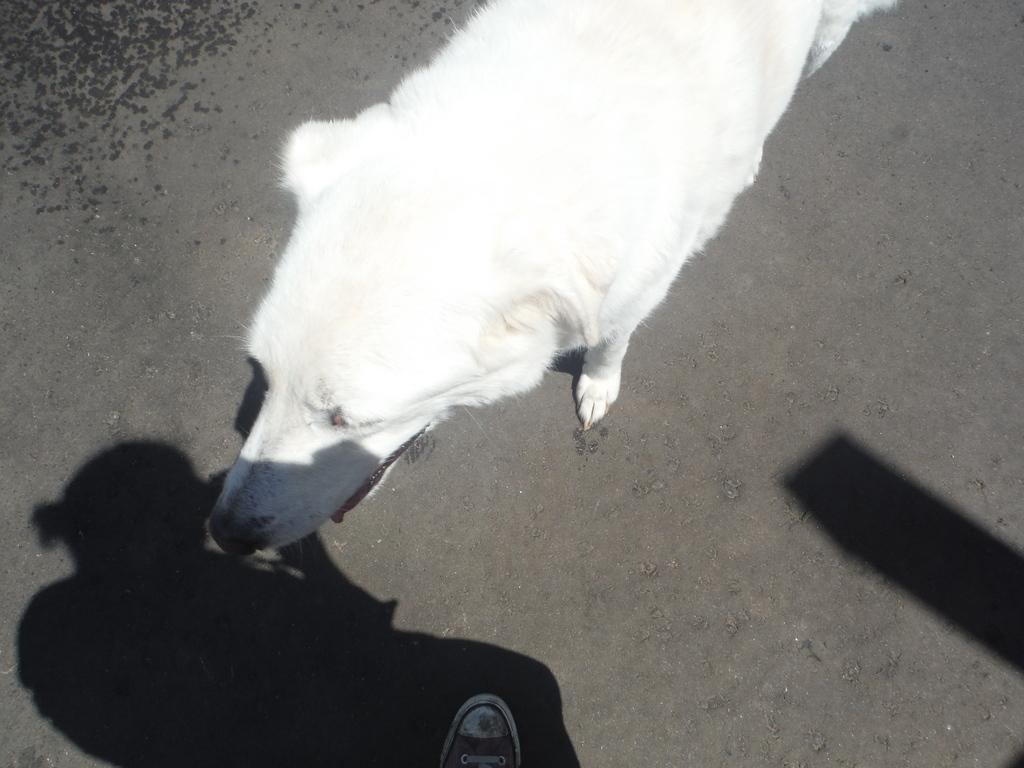What type of animal is in the image? There is a white dog in the image. Where is the dog located? The dog is on the road. Can you see any human body parts in the image? Yes, a human leg is visible in the image. What else is present in the image related to a human? There is a shadow of a human in the image. How many girls are playing with the fairies in the image? There are no girls or fairies present in the image; it features a white dog on the road and a human shadow. What type of medical facility is depicted in the image? There is no hospital or any medical facility present in the image. 